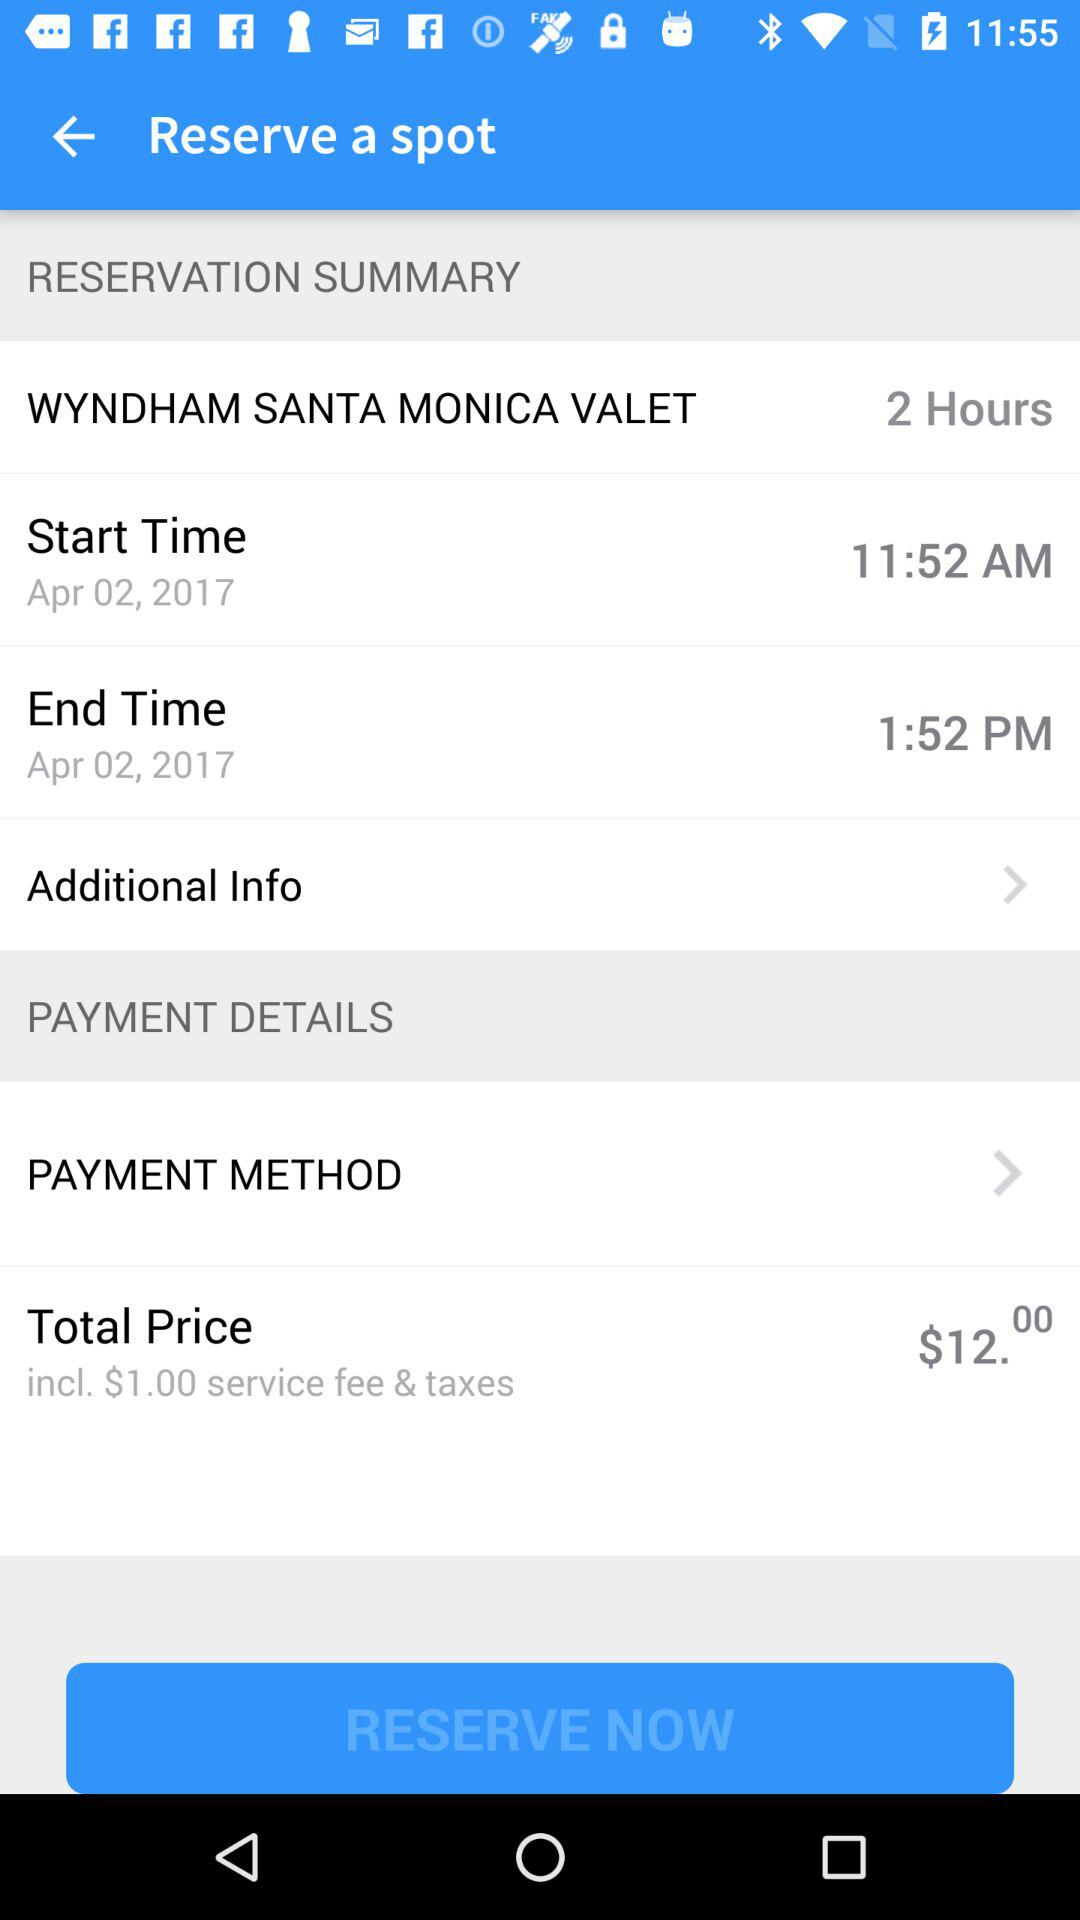What is the date for which the spot has been reserved? The date for which the spot has been reserved is April 2, 2017. 